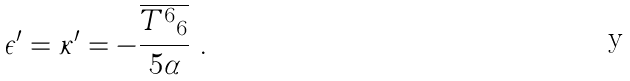Convert formula to latex. <formula><loc_0><loc_0><loc_500><loc_500>\epsilon ^ { \prime } = \kappa ^ { \prime } = - \frac { \overline { { { { T ^ { 6 } } _ { 6 } } } } } { 5 \alpha } \ .</formula> 